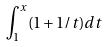<formula> <loc_0><loc_0><loc_500><loc_500>\int _ { 1 } ^ { x } ( 1 + 1 / t ) d t</formula> 